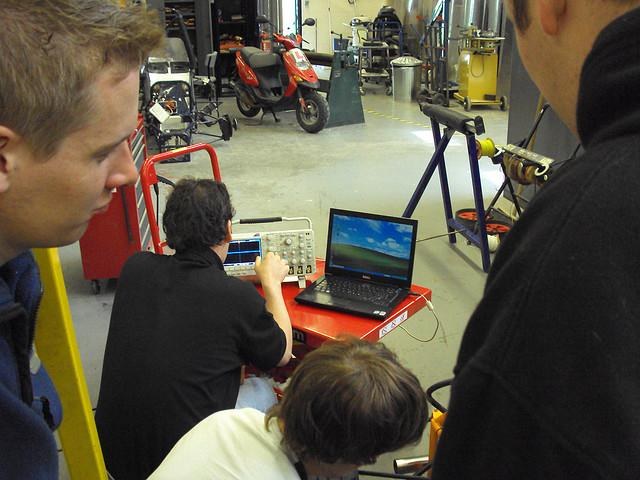What is the man using to control the grey device? knobs 